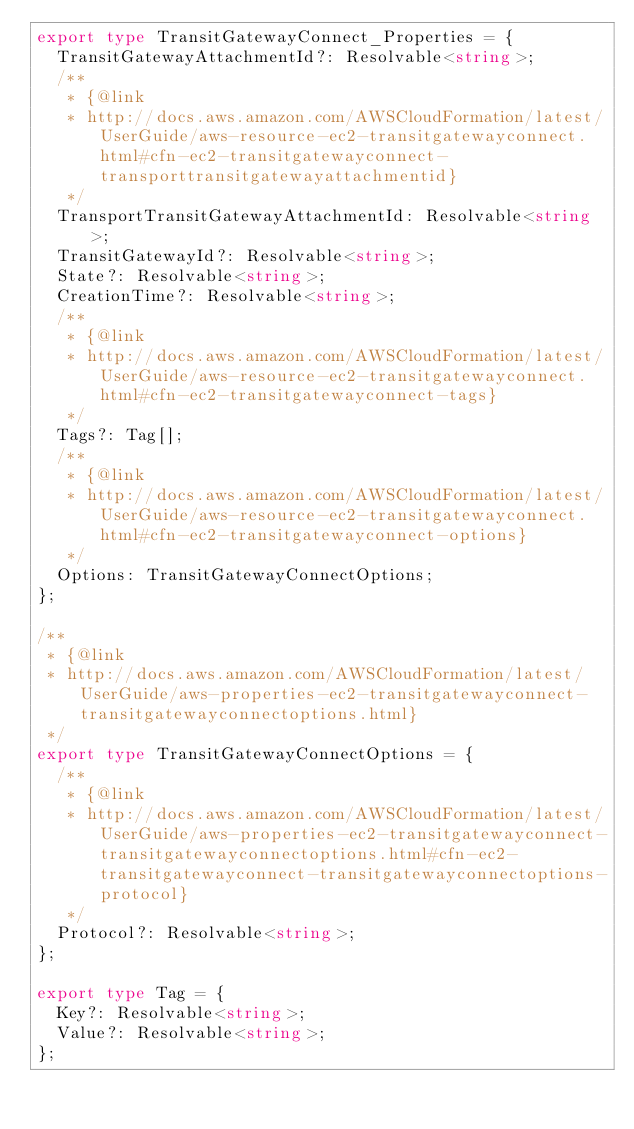<code> <loc_0><loc_0><loc_500><loc_500><_TypeScript_>export type TransitGatewayConnect_Properties = {
  TransitGatewayAttachmentId?: Resolvable<string>;
  /**
   * {@link
   * http://docs.aws.amazon.com/AWSCloudFormation/latest/UserGuide/aws-resource-ec2-transitgatewayconnect.html#cfn-ec2-transitgatewayconnect-transporttransitgatewayattachmentid}
   */
  TransportTransitGatewayAttachmentId: Resolvable<string>;
  TransitGatewayId?: Resolvable<string>;
  State?: Resolvable<string>;
  CreationTime?: Resolvable<string>;
  /**
   * {@link
   * http://docs.aws.amazon.com/AWSCloudFormation/latest/UserGuide/aws-resource-ec2-transitgatewayconnect.html#cfn-ec2-transitgatewayconnect-tags}
   */
  Tags?: Tag[];
  /**
   * {@link
   * http://docs.aws.amazon.com/AWSCloudFormation/latest/UserGuide/aws-resource-ec2-transitgatewayconnect.html#cfn-ec2-transitgatewayconnect-options}
   */
  Options: TransitGatewayConnectOptions;
};

/**
 * {@link
 * http://docs.aws.amazon.com/AWSCloudFormation/latest/UserGuide/aws-properties-ec2-transitgatewayconnect-transitgatewayconnectoptions.html}
 */
export type TransitGatewayConnectOptions = {
  /**
   * {@link
   * http://docs.aws.amazon.com/AWSCloudFormation/latest/UserGuide/aws-properties-ec2-transitgatewayconnect-transitgatewayconnectoptions.html#cfn-ec2-transitgatewayconnect-transitgatewayconnectoptions-protocol}
   */
  Protocol?: Resolvable<string>;
};

export type Tag = {
  Key?: Resolvable<string>;
  Value?: Resolvable<string>;
};
</code> 